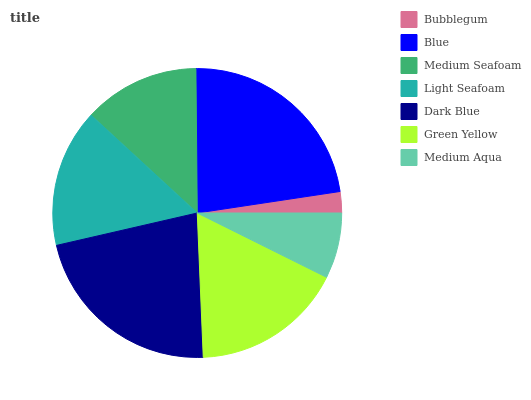Is Bubblegum the minimum?
Answer yes or no. Yes. Is Blue the maximum?
Answer yes or no. Yes. Is Medium Seafoam the minimum?
Answer yes or no. No. Is Medium Seafoam the maximum?
Answer yes or no. No. Is Blue greater than Medium Seafoam?
Answer yes or no. Yes. Is Medium Seafoam less than Blue?
Answer yes or no. Yes. Is Medium Seafoam greater than Blue?
Answer yes or no. No. Is Blue less than Medium Seafoam?
Answer yes or no. No. Is Light Seafoam the high median?
Answer yes or no. Yes. Is Light Seafoam the low median?
Answer yes or no. Yes. Is Blue the high median?
Answer yes or no. No. Is Blue the low median?
Answer yes or no. No. 